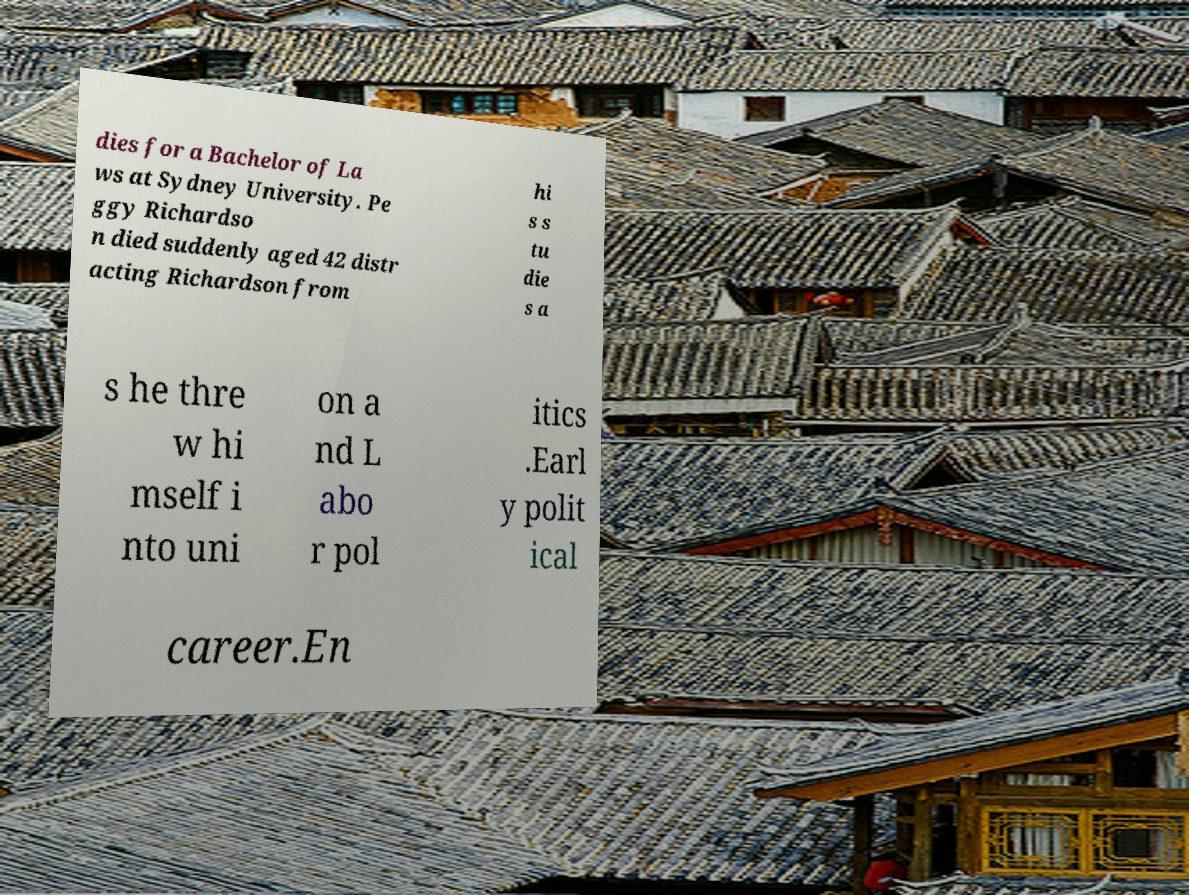For documentation purposes, I need the text within this image transcribed. Could you provide that? dies for a Bachelor of La ws at Sydney University. Pe ggy Richardso n died suddenly aged 42 distr acting Richardson from hi s s tu die s a s he thre w hi mself i nto uni on a nd L abo r pol itics .Earl y polit ical career.En 